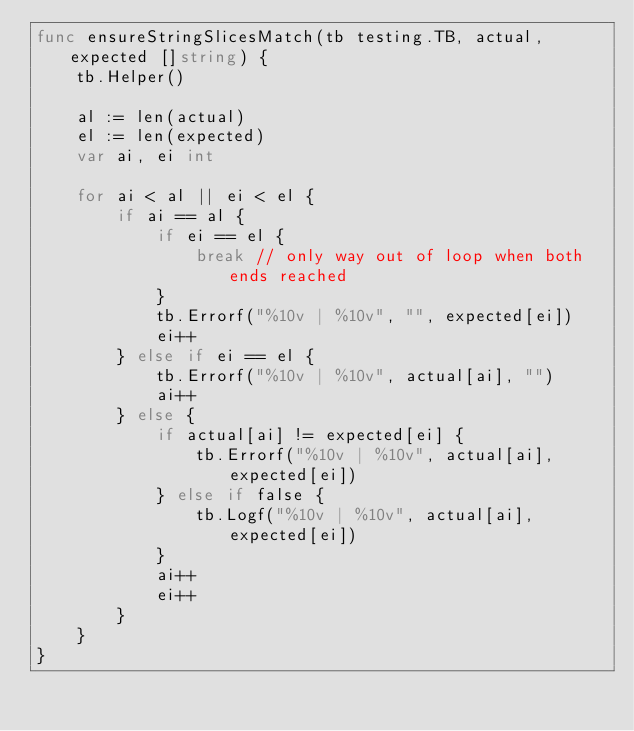Convert code to text. <code><loc_0><loc_0><loc_500><loc_500><_Go_>func ensureStringSlicesMatch(tb testing.TB, actual, expected []string) {
	tb.Helper()

	al := len(actual)
	el := len(expected)
	var ai, ei int

	for ai < al || ei < el {
		if ai == al {
			if ei == el {
				break // only way out of loop when both ends reached
			}
			tb.Errorf("%10v | %10v", "", expected[ei])
			ei++
		} else if ei == el {
			tb.Errorf("%10v | %10v", actual[ai], "")
			ai++
		} else {
			if actual[ai] != expected[ei] {
				tb.Errorf("%10v | %10v", actual[ai], expected[ei])
			} else if false {
				tb.Logf("%10v | %10v", actual[ai], expected[ei])
			}
			ai++
			ei++
		}
	}
}
</code> 